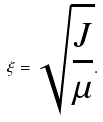Convert formula to latex. <formula><loc_0><loc_0><loc_500><loc_500>\xi = \sqrt { \frac { J } { \mu } } .</formula> 